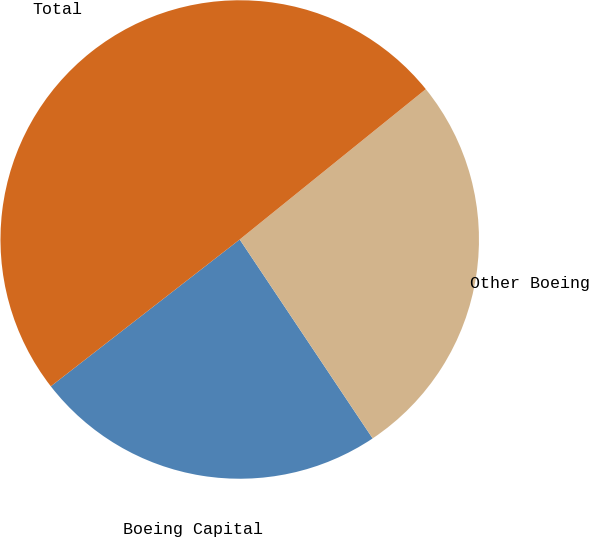<chart> <loc_0><loc_0><loc_500><loc_500><pie_chart><fcel>Boeing Capital<fcel>Other Boeing<fcel>Total<nl><fcel>23.86%<fcel>26.44%<fcel>49.7%<nl></chart> 